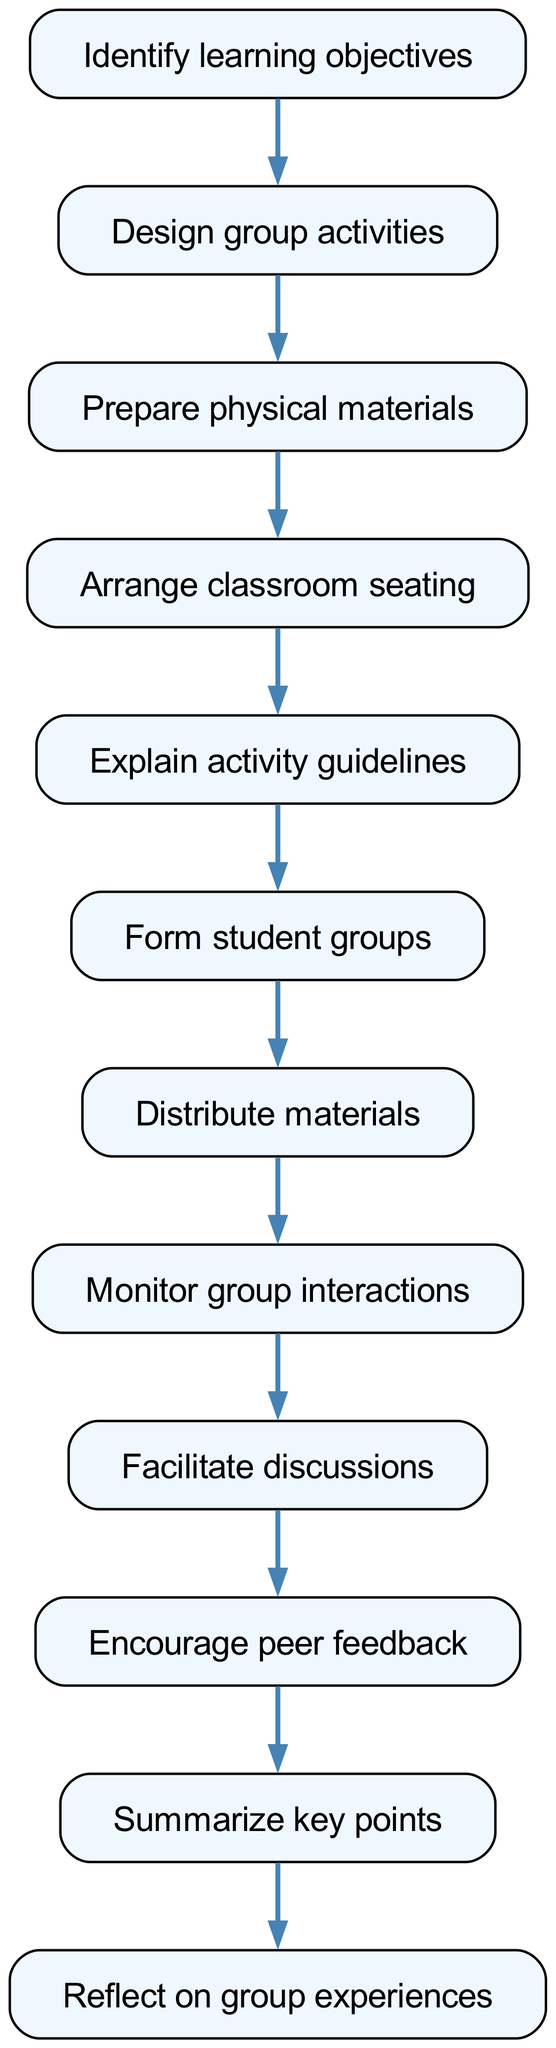What is the first step in the diagram? The diagram begins with identifying the learning objectives as the first step, which is represented by the node with ID 1.
Answer: Identify learning objectives How many steps are there in total? Counting all the nodes from 1 to 12 gives us a total of 12 steps in the flow chart.
Answer: 12 Which step follows after 'Prepare physical materials'? After the step 'Prepare physical materials', which is step 3, the flow leads to step 4, which is 'Arrange classroom seating'.
Answer: Arrange classroom seating What is the last step in the flow chart? The last step in the flow chart is 'Reflect on group experiences', which is represented by node 12, with no following step indicated.
Answer: Reflect on group experiences How many connections or edges are there in the diagram? Each step connects to the next, and there are 11 connections from node 1 to node 12, leading to a total of 11 edges.
Answer: 11 What activity occurs before 'Facilitate discussions'? The step just before 'Facilitate discussions', which corresponds to node 9, is 'Monitor group interactions', which is step 8 following it.
Answer: Monitor group interactions What are the activity guidelines related to? The activity guidelines pertain to the group activities, and this is explained during the step 'Explain activity guidelines', which follows ‘Arrange classroom seating’.
Answer: Group activities Which step emphasizes peer feedback? The step that emphasizes peer feedback is 'Encourage peer feedback', which is step 10 in the flow chart, highlighting its importance in collaborative learning.
Answer: Encourage peer feedback What is the common purpose of all the steps? Each step in the flow chart collectively aims to implement collaborative learning activities effectively in a classroom setting without the use of technology.
Answer: Implement collaborative learning activities 